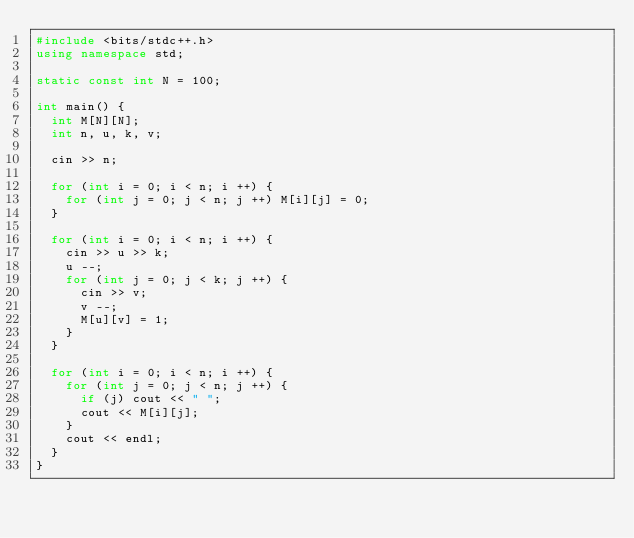<code> <loc_0><loc_0><loc_500><loc_500><_C++_>#include <bits/stdc++.h>
using namespace std;

static const int N = 100;

int main() {
  int M[N][N];
  int n, u, k, v;

  cin >> n;

  for (int i = 0; i < n; i ++) {
    for (int j = 0; j < n; j ++) M[i][j] = 0;
  }

  for (int i = 0; i < n; i ++) {
    cin >> u >> k;
    u --;
    for (int j = 0; j < k; j ++) {
      cin >> v;
      v --;
      M[u][v] = 1;
    }
  }

  for (int i = 0; i < n; i ++) {
    for (int j = 0; j < n; j ++) {
      if (j) cout << " ";
      cout << M[i][j];
    }
    cout << endl;
  }
}

</code> 